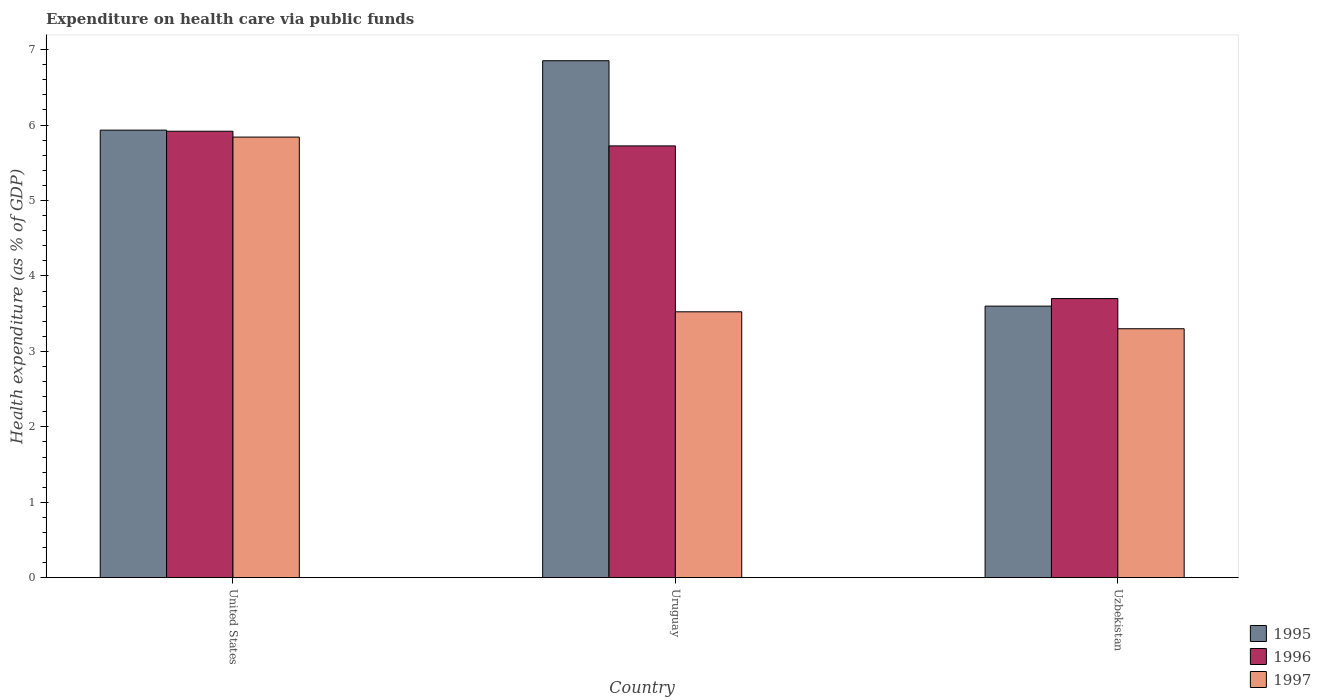How many different coloured bars are there?
Ensure brevity in your answer.  3. How many groups of bars are there?
Your answer should be very brief. 3. How many bars are there on the 3rd tick from the left?
Your answer should be very brief. 3. How many bars are there on the 1st tick from the right?
Offer a terse response. 3. In how many cases, is the number of bars for a given country not equal to the number of legend labels?
Provide a short and direct response. 0. What is the expenditure made on health care in 1996 in Uzbekistan?
Make the answer very short. 3.7. Across all countries, what is the maximum expenditure made on health care in 1996?
Make the answer very short. 5.92. Across all countries, what is the minimum expenditure made on health care in 1995?
Your answer should be very brief. 3.6. In which country was the expenditure made on health care in 1997 maximum?
Keep it short and to the point. United States. In which country was the expenditure made on health care in 1995 minimum?
Give a very brief answer. Uzbekistan. What is the total expenditure made on health care in 1995 in the graph?
Your answer should be very brief. 16.39. What is the difference between the expenditure made on health care in 1996 in United States and that in Uzbekistan?
Ensure brevity in your answer.  2.22. What is the difference between the expenditure made on health care in 1996 in United States and the expenditure made on health care in 1997 in Uruguay?
Make the answer very short. 2.39. What is the average expenditure made on health care in 1996 per country?
Your response must be concise. 5.11. What is the difference between the expenditure made on health care of/in 1995 and expenditure made on health care of/in 1996 in United States?
Your answer should be compact. 0.01. In how many countries, is the expenditure made on health care in 1997 greater than 4.8 %?
Make the answer very short. 1. What is the ratio of the expenditure made on health care in 1996 in United States to that in Uzbekistan?
Ensure brevity in your answer.  1.6. Is the expenditure made on health care in 1995 in Uruguay less than that in Uzbekistan?
Keep it short and to the point. No. Is the difference between the expenditure made on health care in 1995 in United States and Uzbekistan greater than the difference between the expenditure made on health care in 1996 in United States and Uzbekistan?
Give a very brief answer. Yes. What is the difference between the highest and the second highest expenditure made on health care in 1996?
Make the answer very short. 2.02. What is the difference between the highest and the lowest expenditure made on health care in 1996?
Your answer should be compact. 2.22. In how many countries, is the expenditure made on health care in 1995 greater than the average expenditure made on health care in 1995 taken over all countries?
Give a very brief answer. 2. Is the sum of the expenditure made on health care in 1997 in United States and Uzbekistan greater than the maximum expenditure made on health care in 1996 across all countries?
Provide a succinct answer. Yes. What does the 1st bar from the left in Uzbekistan represents?
Your answer should be very brief. 1995. What does the 3rd bar from the right in Uzbekistan represents?
Your answer should be compact. 1995. How many bars are there?
Offer a terse response. 9. What is the difference between two consecutive major ticks on the Y-axis?
Provide a succinct answer. 1. Does the graph contain any zero values?
Your answer should be very brief. No. Where does the legend appear in the graph?
Offer a terse response. Bottom right. How are the legend labels stacked?
Your response must be concise. Vertical. What is the title of the graph?
Your answer should be compact. Expenditure on health care via public funds. What is the label or title of the Y-axis?
Keep it short and to the point. Health expenditure (as % of GDP). What is the Health expenditure (as % of GDP) in 1995 in United States?
Make the answer very short. 5.93. What is the Health expenditure (as % of GDP) of 1996 in United States?
Your answer should be compact. 5.92. What is the Health expenditure (as % of GDP) of 1997 in United States?
Your response must be concise. 5.84. What is the Health expenditure (as % of GDP) of 1995 in Uruguay?
Provide a succinct answer. 6.85. What is the Health expenditure (as % of GDP) of 1996 in Uruguay?
Provide a short and direct response. 5.72. What is the Health expenditure (as % of GDP) in 1997 in Uruguay?
Your answer should be compact. 3.52. What is the Health expenditure (as % of GDP) of 1995 in Uzbekistan?
Give a very brief answer. 3.6. What is the Health expenditure (as % of GDP) in 1996 in Uzbekistan?
Your answer should be very brief. 3.7. What is the Health expenditure (as % of GDP) in 1997 in Uzbekistan?
Offer a terse response. 3.3. Across all countries, what is the maximum Health expenditure (as % of GDP) in 1995?
Provide a succinct answer. 6.85. Across all countries, what is the maximum Health expenditure (as % of GDP) in 1996?
Offer a very short reply. 5.92. Across all countries, what is the maximum Health expenditure (as % of GDP) of 1997?
Offer a terse response. 5.84. Across all countries, what is the minimum Health expenditure (as % of GDP) in 1995?
Make the answer very short. 3.6. Across all countries, what is the minimum Health expenditure (as % of GDP) of 1996?
Your answer should be compact. 3.7. Across all countries, what is the minimum Health expenditure (as % of GDP) in 1997?
Make the answer very short. 3.3. What is the total Health expenditure (as % of GDP) in 1995 in the graph?
Provide a succinct answer. 16.39. What is the total Health expenditure (as % of GDP) of 1996 in the graph?
Offer a terse response. 15.34. What is the total Health expenditure (as % of GDP) in 1997 in the graph?
Ensure brevity in your answer.  12.67. What is the difference between the Health expenditure (as % of GDP) in 1995 in United States and that in Uruguay?
Your answer should be compact. -0.92. What is the difference between the Health expenditure (as % of GDP) in 1996 in United States and that in Uruguay?
Make the answer very short. 0.19. What is the difference between the Health expenditure (as % of GDP) in 1997 in United States and that in Uruguay?
Offer a very short reply. 2.32. What is the difference between the Health expenditure (as % of GDP) of 1995 in United States and that in Uzbekistan?
Offer a terse response. 2.33. What is the difference between the Health expenditure (as % of GDP) of 1996 in United States and that in Uzbekistan?
Your answer should be very brief. 2.22. What is the difference between the Health expenditure (as % of GDP) of 1997 in United States and that in Uzbekistan?
Your answer should be compact. 2.54. What is the difference between the Health expenditure (as % of GDP) of 1995 in Uruguay and that in Uzbekistan?
Your answer should be very brief. 3.25. What is the difference between the Health expenditure (as % of GDP) in 1996 in Uruguay and that in Uzbekistan?
Ensure brevity in your answer.  2.02. What is the difference between the Health expenditure (as % of GDP) of 1997 in Uruguay and that in Uzbekistan?
Make the answer very short. 0.22. What is the difference between the Health expenditure (as % of GDP) of 1995 in United States and the Health expenditure (as % of GDP) of 1996 in Uruguay?
Provide a short and direct response. 0.21. What is the difference between the Health expenditure (as % of GDP) of 1995 in United States and the Health expenditure (as % of GDP) of 1997 in Uruguay?
Keep it short and to the point. 2.41. What is the difference between the Health expenditure (as % of GDP) of 1996 in United States and the Health expenditure (as % of GDP) of 1997 in Uruguay?
Keep it short and to the point. 2.39. What is the difference between the Health expenditure (as % of GDP) in 1995 in United States and the Health expenditure (as % of GDP) in 1996 in Uzbekistan?
Your response must be concise. 2.23. What is the difference between the Health expenditure (as % of GDP) in 1995 in United States and the Health expenditure (as % of GDP) in 1997 in Uzbekistan?
Ensure brevity in your answer.  2.63. What is the difference between the Health expenditure (as % of GDP) of 1996 in United States and the Health expenditure (as % of GDP) of 1997 in Uzbekistan?
Offer a very short reply. 2.62. What is the difference between the Health expenditure (as % of GDP) in 1995 in Uruguay and the Health expenditure (as % of GDP) in 1996 in Uzbekistan?
Your answer should be compact. 3.15. What is the difference between the Health expenditure (as % of GDP) in 1995 in Uruguay and the Health expenditure (as % of GDP) in 1997 in Uzbekistan?
Provide a succinct answer. 3.55. What is the difference between the Health expenditure (as % of GDP) in 1996 in Uruguay and the Health expenditure (as % of GDP) in 1997 in Uzbekistan?
Give a very brief answer. 2.42. What is the average Health expenditure (as % of GDP) in 1995 per country?
Your answer should be very brief. 5.46. What is the average Health expenditure (as % of GDP) of 1996 per country?
Make the answer very short. 5.11. What is the average Health expenditure (as % of GDP) of 1997 per country?
Keep it short and to the point. 4.22. What is the difference between the Health expenditure (as % of GDP) in 1995 and Health expenditure (as % of GDP) in 1996 in United States?
Offer a very short reply. 0.01. What is the difference between the Health expenditure (as % of GDP) in 1995 and Health expenditure (as % of GDP) in 1997 in United States?
Give a very brief answer. 0.09. What is the difference between the Health expenditure (as % of GDP) of 1996 and Health expenditure (as % of GDP) of 1997 in United States?
Give a very brief answer. 0.08. What is the difference between the Health expenditure (as % of GDP) in 1995 and Health expenditure (as % of GDP) in 1996 in Uruguay?
Offer a terse response. 1.13. What is the difference between the Health expenditure (as % of GDP) of 1995 and Health expenditure (as % of GDP) of 1997 in Uruguay?
Give a very brief answer. 3.33. What is the difference between the Health expenditure (as % of GDP) in 1996 and Health expenditure (as % of GDP) in 1997 in Uruguay?
Offer a terse response. 2.2. What is the difference between the Health expenditure (as % of GDP) in 1995 and Health expenditure (as % of GDP) in 1997 in Uzbekistan?
Give a very brief answer. 0.3. What is the ratio of the Health expenditure (as % of GDP) of 1995 in United States to that in Uruguay?
Offer a terse response. 0.87. What is the ratio of the Health expenditure (as % of GDP) of 1996 in United States to that in Uruguay?
Ensure brevity in your answer.  1.03. What is the ratio of the Health expenditure (as % of GDP) in 1997 in United States to that in Uruguay?
Make the answer very short. 1.66. What is the ratio of the Health expenditure (as % of GDP) of 1995 in United States to that in Uzbekistan?
Your answer should be compact. 1.65. What is the ratio of the Health expenditure (as % of GDP) of 1996 in United States to that in Uzbekistan?
Your answer should be compact. 1.6. What is the ratio of the Health expenditure (as % of GDP) in 1997 in United States to that in Uzbekistan?
Provide a short and direct response. 1.77. What is the ratio of the Health expenditure (as % of GDP) of 1995 in Uruguay to that in Uzbekistan?
Your answer should be compact. 1.9. What is the ratio of the Health expenditure (as % of GDP) of 1996 in Uruguay to that in Uzbekistan?
Ensure brevity in your answer.  1.55. What is the ratio of the Health expenditure (as % of GDP) of 1997 in Uruguay to that in Uzbekistan?
Ensure brevity in your answer.  1.07. What is the difference between the highest and the second highest Health expenditure (as % of GDP) of 1995?
Your answer should be compact. 0.92. What is the difference between the highest and the second highest Health expenditure (as % of GDP) of 1996?
Offer a terse response. 0.19. What is the difference between the highest and the second highest Health expenditure (as % of GDP) in 1997?
Keep it short and to the point. 2.32. What is the difference between the highest and the lowest Health expenditure (as % of GDP) of 1995?
Provide a succinct answer. 3.25. What is the difference between the highest and the lowest Health expenditure (as % of GDP) in 1996?
Ensure brevity in your answer.  2.22. What is the difference between the highest and the lowest Health expenditure (as % of GDP) of 1997?
Your answer should be compact. 2.54. 